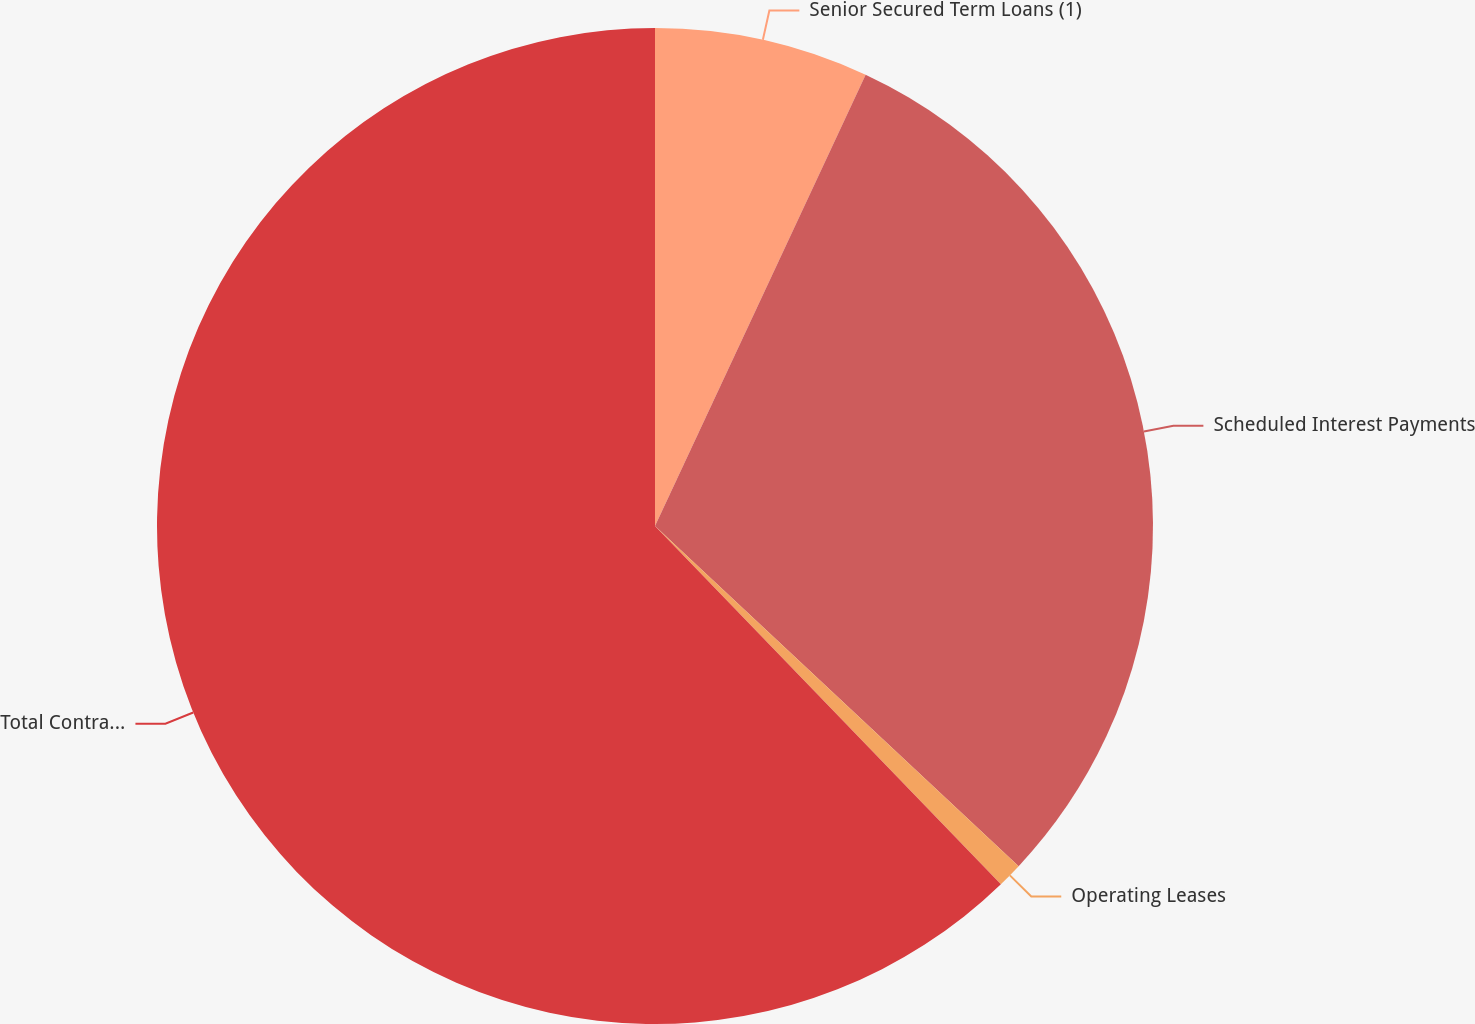Convert chart to OTSL. <chart><loc_0><loc_0><loc_500><loc_500><pie_chart><fcel>Senior Secured Term Loans (1)<fcel>Scheduled Interest Payments<fcel>Operating Leases<fcel>Total Contractual Cash<nl><fcel>6.95%<fcel>30.02%<fcel>0.81%<fcel>62.22%<nl></chart> 